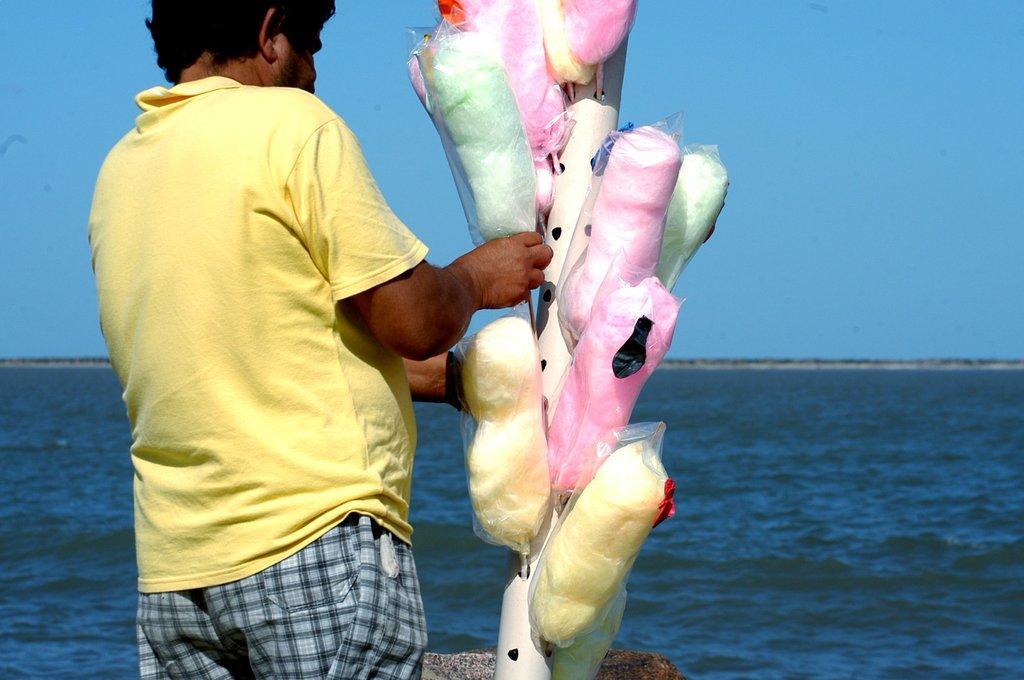Can you describe this image briefly? In the center of the image a man is standing and holding a cotton candy. In the background of the image water is there. At the top of the image sky is there. 